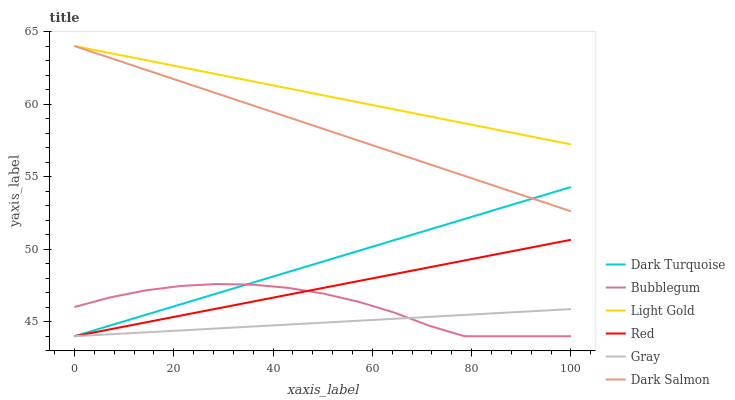Does Gray have the minimum area under the curve?
Answer yes or no. Yes. Does Light Gold have the maximum area under the curve?
Answer yes or no. Yes. Does Dark Turquoise have the minimum area under the curve?
Answer yes or no. No. Does Dark Turquoise have the maximum area under the curve?
Answer yes or no. No. Is Dark Turquoise the smoothest?
Answer yes or no. Yes. Is Bubblegum the roughest?
Answer yes or no. Yes. Is Dark Salmon the smoothest?
Answer yes or no. No. Is Dark Salmon the roughest?
Answer yes or no. No. Does Gray have the lowest value?
Answer yes or no. Yes. Does Dark Salmon have the lowest value?
Answer yes or no. No. Does Light Gold have the highest value?
Answer yes or no. Yes. Does Dark Turquoise have the highest value?
Answer yes or no. No. Is Dark Turquoise less than Light Gold?
Answer yes or no. Yes. Is Light Gold greater than Dark Turquoise?
Answer yes or no. Yes. Does Dark Turquoise intersect Bubblegum?
Answer yes or no. Yes. Is Dark Turquoise less than Bubblegum?
Answer yes or no. No. Is Dark Turquoise greater than Bubblegum?
Answer yes or no. No. Does Dark Turquoise intersect Light Gold?
Answer yes or no. No. 